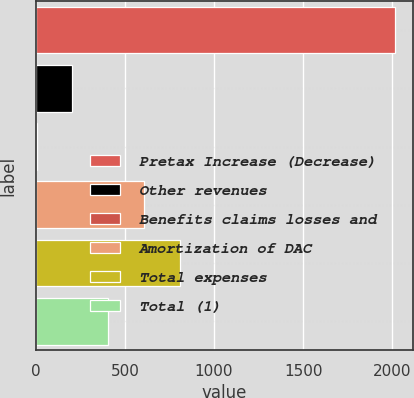Convert chart. <chart><loc_0><loc_0><loc_500><loc_500><bar_chart><fcel>Pretax Increase (Decrease)<fcel>Other revenues<fcel>Benefits claims losses and<fcel>Amortization of DAC<fcel>Total expenses<fcel>Total (1)<nl><fcel>2013<fcel>205.8<fcel>5<fcel>607.4<fcel>808.2<fcel>406.6<nl></chart> 